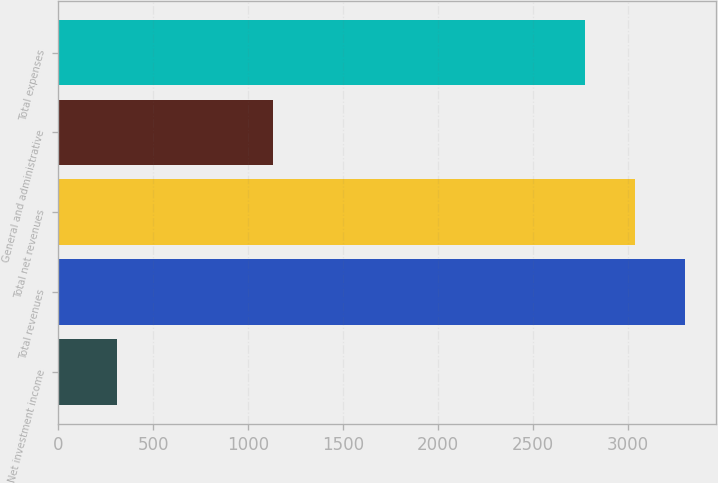Convert chart. <chart><loc_0><loc_0><loc_500><loc_500><bar_chart><fcel>Net investment income<fcel>Total revenues<fcel>Total net revenues<fcel>General and administrative<fcel>Total expenses<nl><fcel>308<fcel>3301.8<fcel>3037.4<fcel>1129<fcel>2773<nl></chart> 